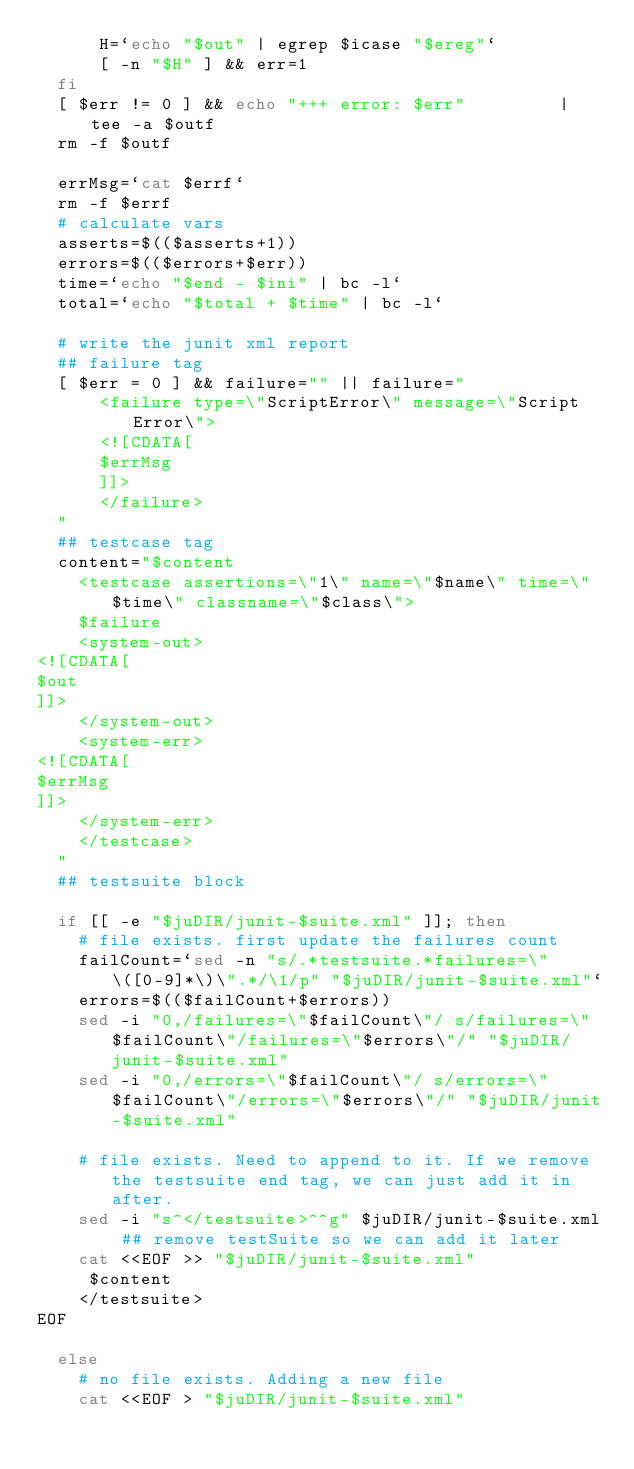<code> <loc_0><loc_0><loc_500><loc_500><_Bash_>      H=`echo "$out" | egrep $icase "$ereg"`
      [ -n "$H" ] && err=1
  fi
  [ $err != 0 ] && echo "+++ error: $err"         | tee -a $outf
  rm -f $outf

  errMsg=`cat $errf`
  rm -f $errf
  # calculate vars
  asserts=$(($asserts+1))
  errors=$(($errors+$err))
  time=`echo "$end - $ini" | bc -l`
  total=`echo "$total + $time" | bc -l`

  # write the junit xml report
  ## failure tag
  [ $err = 0 ] && failure="" || failure="
      <failure type=\"ScriptError\" message=\"Script Error\">
      <![CDATA[
      $errMsg
      ]]>
      </failure>
  "
  ## testcase tag
  content="$content
    <testcase assertions=\"1\" name=\"$name\" time=\"$time\" classname=\"$class\">
    $failure
    <system-out>
<![CDATA[
$out
]]>
    </system-out>
    <system-err>
<![CDATA[
$errMsg
]]>
    </system-err>
    </testcase>
  "
  ## testsuite block

  if [[ -e "$juDIR/junit-$suite.xml" ]]; then
    # file exists. first update the failures count
    failCount=`sed -n "s/.*testsuite.*failures=\"\([0-9]*\)\".*/\1/p" "$juDIR/junit-$suite.xml"`
    errors=$(($failCount+$errors))
    sed -i "0,/failures=\"$failCount\"/ s/failures=\"$failCount\"/failures=\"$errors\"/" "$juDIR/junit-$suite.xml"
    sed -i "0,/errors=\"$failCount\"/ s/errors=\"$failCount\"/errors=\"$errors\"/" "$juDIR/junit-$suite.xml"

    # file exists. Need to append to it. If we remove the testsuite end tag, we can just add it in after.
    sed -i "s^</testsuite>^^g" $juDIR/junit-$suite.xml ## remove testSuite so we can add it later
    cat <<EOF >> "$juDIR/junit-$suite.xml"
     $content
    </testsuite>
EOF

  else
    # no file exists. Adding a new file
    cat <<EOF > "$juDIR/junit-$suite.xml"</code> 